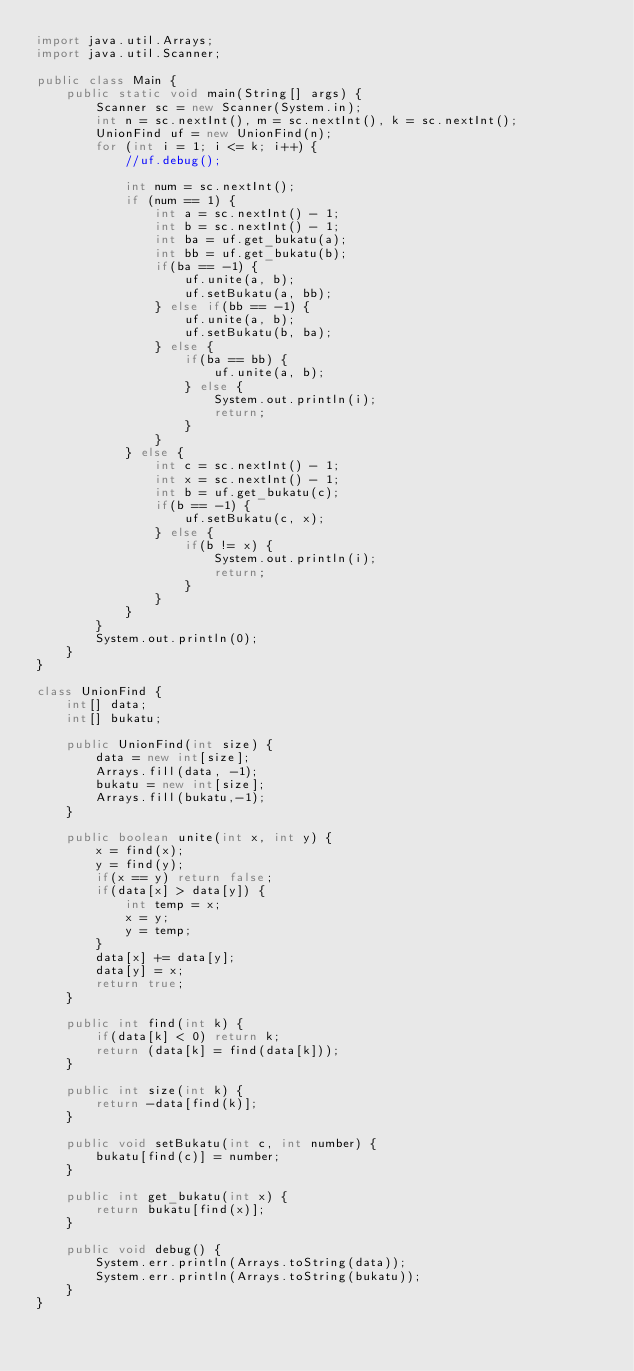Convert code to text. <code><loc_0><loc_0><loc_500><loc_500><_Java_>import java.util.Arrays;
import java.util.Scanner;

public class Main {
    public static void main(String[] args) {
        Scanner sc = new Scanner(System.in);
        int n = sc.nextInt(), m = sc.nextInt(), k = sc.nextInt();
        UnionFind uf = new UnionFind(n);
        for (int i = 1; i <= k; i++) {
            //uf.debug();

            int num = sc.nextInt();
            if (num == 1) {
                int a = sc.nextInt() - 1;
                int b = sc.nextInt() - 1;
                int ba = uf.get_bukatu(a);
                int bb = uf.get_bukatu(b);
                if(ba == -1) {
                    uf.unite(a, b);
                    uf.setBukatu(a, bb);
                } else if(bb == -1) {
                    uf.unite(a, b);
                    uf.setBukatu(b, ba);
                } else {
                    if(ba == bb) {
                        uf.unite(a, b);
                    } else {
                        System.out.println(i);
                        return;
                    }
                }
            } else {
                int c = sc.nextInt() - 1;
                int x = sc.nextInt() - 1;
                int b = uf.get_bukatu(c);
                if(b == -1) {
                    uf.setBukatu(c, x);
                } else {
                    if(b != x) {
                        System.out.println(i);
                        return;
                    }
                }
            }
        }
        System.out.println(0);
    }
}

class UnionFind {
    int[] data;
    int[] bukatu;

    public UnionFind(int size) {
        data = new int[size];
        Arrays.fill(data, -1);
        bukatu = new int[size];
        Arrays.fill(bukatu,-1);
    }

    public boolean unite(int x, int y) {
        x = find(x);
        y = find(y);
        if(x == y) return false;
        if(data[x] > data[y]) {
            int temp = x;
            x = y;
            y = temp;
        }
        data[x] += data[y];
        data[y] = x;
        return true;
    }

    public int find(int k) {
        if(data[k] < 0) return k;
        return (data[k] = find(data[k]));
    }

    public int size(int k) {
        return -data[find(k)];
    }

    public void setBukatu(int c, int number) {
        bukatu[find(c)] = number;
    }

    public int get_bukatu(int x) {
        return bukatu[find(x)];
    }

    public void debug() {
        System.err.println(Arrays.toString(data));
        System.err.println(Arrays.toString(bukatu));
    }
}
</code> 